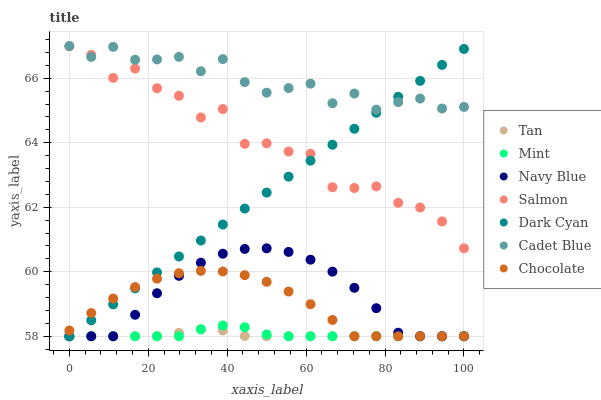Does Tan have the minimum area under the curve?
Answer yes or no. Yes. Does Cadet Blue have the maximum area under the curve?
Answer yes or no. Yes. Does Navy Blue have the minimum area under the curve?
Answer yes or no. No. Does Navy Blue have the maximum area under the curve?
Answer yes or no. No. Is Dark Cyan the smoothest?
Answer yes or no. Yes. Is Salmon the roughest?
Answer yes or no. Yes. Is Navy Blue the smoothest?
Answer yes or no. No. Is Navy Blue the roughest?
Answer yes or no. No. Does Navy Blue have the lowest value?
Answer yes or no. Yes. Does Salmon have the lowest value?
Answer yes or no. No. Does Cadet Blue have the highest value?
Answer yes or no. Yes. Does Navy Blue have the highest value?
Answer yes or no. No. Is Mint less than Salmon?
Answer yes or no. Yes. Is Salmon greater than Navy Blue?
Answer yes or no. Yes. Does Salmon intersect Dark Cyan?
Answer yes or no. Yes. Is Salmon less than Dark Cyan?
Answer yes or no. No. Is Salmon greater than Dark Cyan?
Answer yes or no. No. Does Mint intersect Salmon?
Answer yes or no. No. 